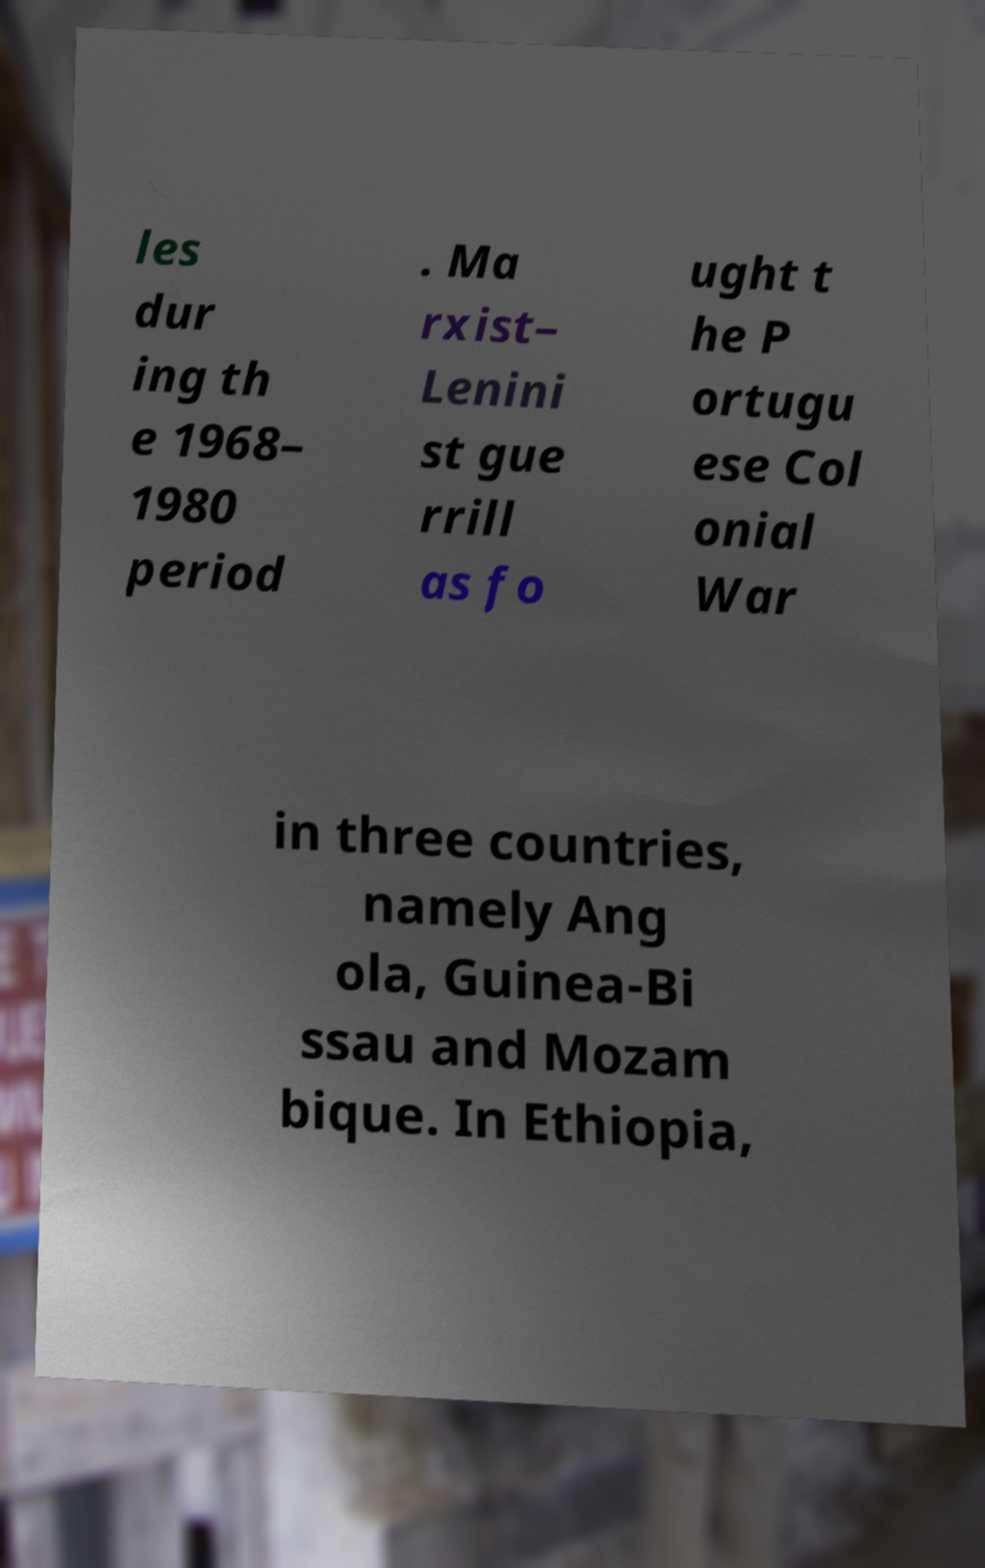I need the written content from this picture converted into text. Can you do that? les dur ing th e 1968– 1980 period . Ma rxist– Lenini st gue rrill as fo ught t he P ortugu ese Col onial War in three countries, namely Ang ola, Guinea-Bi ssau and Mozam bique. In Ethiopia, 